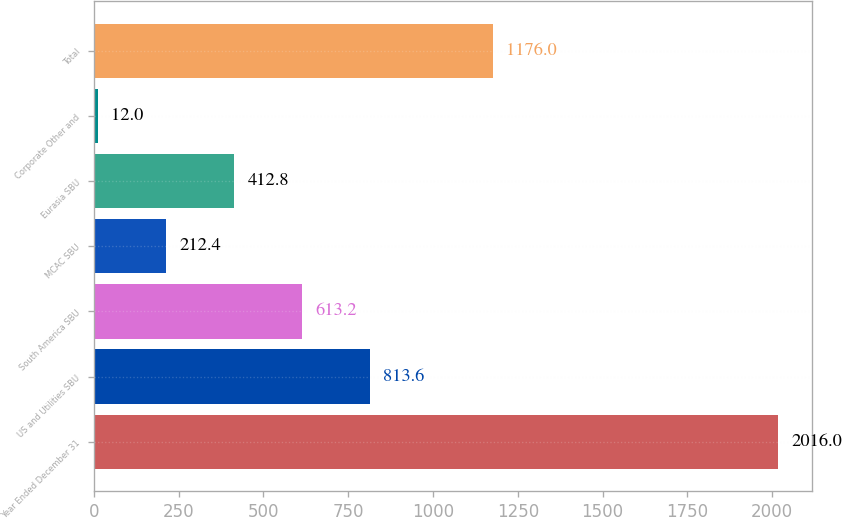Convert chart. <chart><loc_0><loc_0><loc_500><loc_500><bar_chart><fcel>Year Ended December 31<fcel>US and Utilities SBU<fcel>South America SBU<fcel>MCAC SBU<fcel>Eurasia SBU<fcel>Corporate Other and<fcel>Total<nl><fcel>2016<fcel>813.6<fcel>613.2<fcel>212.4<fcel>412.8<fcel>12<fcel>1176<nl></chart> 